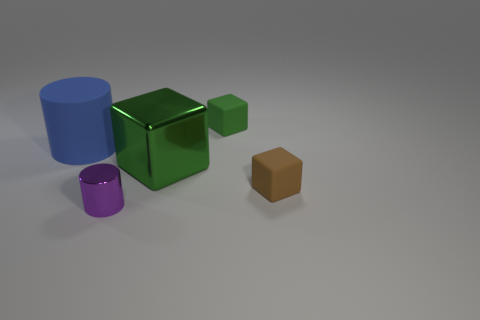Subtract all blue cylinders. How many green cubes are left? 2 Subtract all small matte cubes. How many cubes are left? 1 Add 4 big green metallic things. How many objects exist? 9 Subtract all red cubes. Subtract all cyan cylinders. How many cubes are left? 3 Subtract all cubes. How many objects are left? 2 Add 4 cyan metallic blocks. How many cyan metallic blocks exist? 4 Subtract 0 cyan balls. How many objects are left? 5 Subtract all large cubes. Subtract all big cubes. How many objects are left? 3 Add 5 tiny brown things. How many tiny brown things are left? 6 